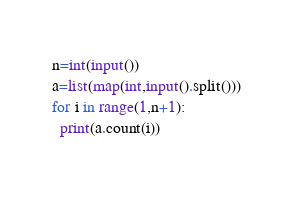<code> <loc_0><loc_0><loc_500><loc_500><_Python_>n=int(input())
a=list(map(int,input().split()))
for i in range(1,n+1):
  print(a.count(i))
  </code> 